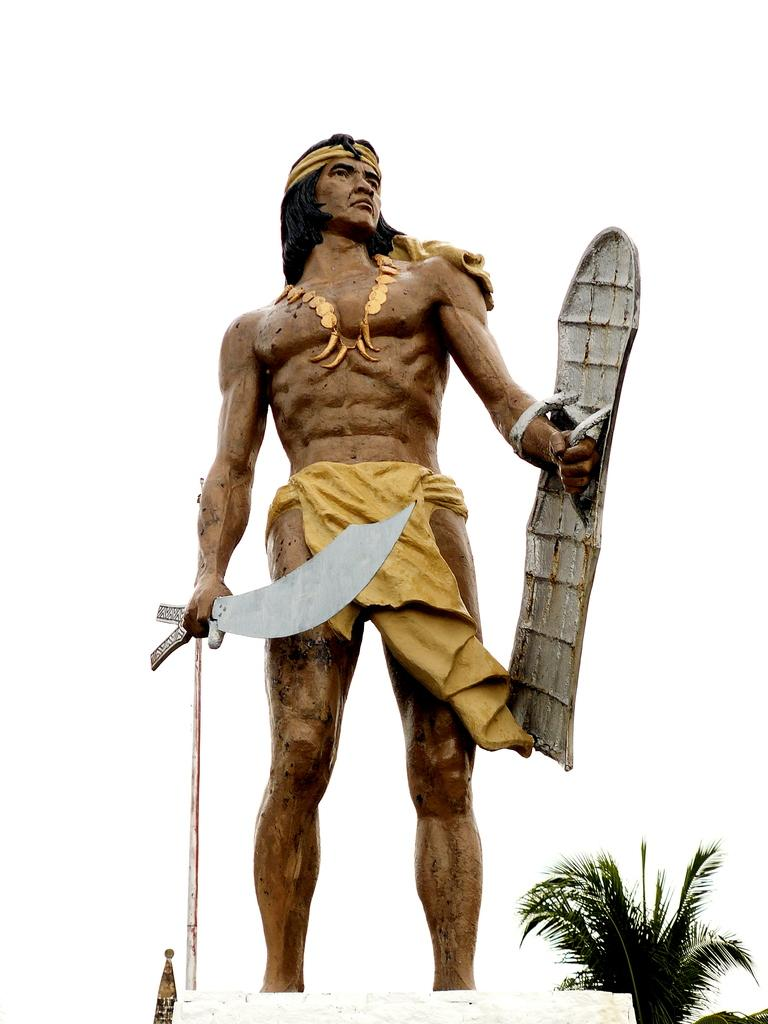What is the main subject of the image? There is a statue of a person in the image. What is the statue holding in its hands? The statue is holding a Chinese war sword and a war shield. What type of vegetation can be seen in the image? There is a tree in the image. What is visible in the background of the image? The sky is visible in the background of the image. How many dogs are present in the image? There are no dogs present in the image; it features a statue holding a Chinese war sword and a war shield, with a tree and the sky visible in the background. Is there a stage visible in the image? There is no stage present in the image. 